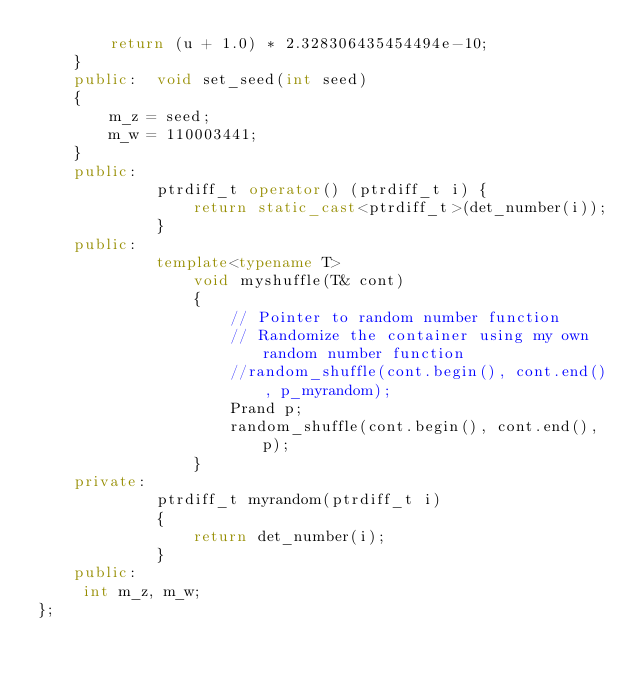Convert code to text. <code><loc_0><loc_0><loc_500><loc_500><_C++_>        return (u + 1.0) * 2.328306435454494e-10;
    }
    public:  void set_seed(int seed)
    {
        m_z = seed;
        m_w = 110003441;
    }
    public: 
             ptrdiff_t operator() (ptrdiff_t i) {
                 return static_cast<ptrdiff_t>(det_number(i));
             }
    public: 
             template<typename T>
                 void myshuffle(T& cont)
                 { 
                     // Pointer to random number function
                     // Randomize the container using my own random number function
                     //random_shuffle(cont.begin(), cont.end(), p_myrandom);
                     Prand p;
                     random_shuffle(cont.begin(), cont.end(), p);
                 }
    private:
             ptrdiff_t myrandom(ptrdiff_t i)
             {
                 return det_number(i);
             }
    public:
     int m_z, m_w;
};
</code> 